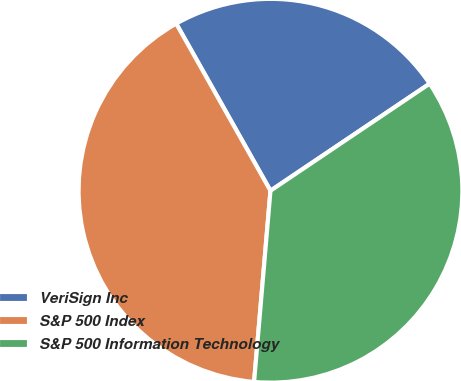Convert chart to OTSL. <chart><loc_0><loc_0><loc_500><loc_500><pie_chart><fcel>VeriSign Inc<fcel>S&P 500 Index<fcel>S&P 500 Information Technology<nl><fcel>23.75%<fcel>40.47%<fcel>35.79%<nl></chart> 